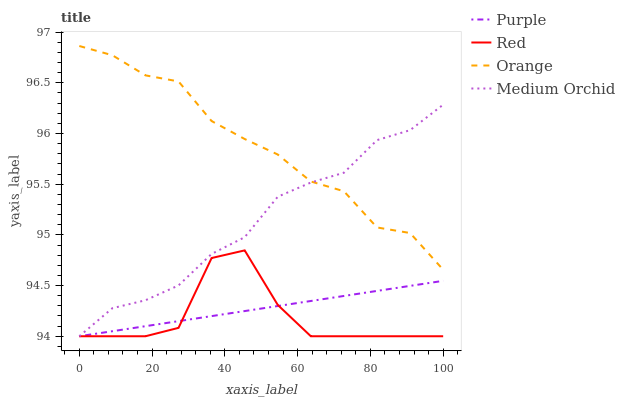Does Red have the minimum area under the curve?
Answer yes or no. Yes. Does Orange have the maximum area under the curve?
Answer yes or no. Yes. Does Medium Orchid have the minimum area under the curve?
Answer yes or no. No. Does Medium Orchid have the maximum area under the curve?
Answer yes or no. No. Is Purple the smoothest?
Answer yes or no. Yes. Is Red the roughest?
Answer yes or no. Yes. Is Orange the smoothest?
Answer yes or no. No. Is Orange the roughest?
Answer yes or no. No. Does Purple have the lowest value?
Answer yes or no. Yes. Does Orange have the lowest value?
Answer yes or no. No. Does Orange have the highest value?
Answer yes or no. Yes. Does Medium Orchid have the highest value?
Answer yes or no. No. Is Purple less than Orange?
Answer yes or no. Yes. Is Orange greater than Red?
Answer yes or no. Yes. Does Medium Orchid intersect Red?
Answer yes or no. Yes. Is Medium Orchid less than Red?
Answer yes or no. No. Is Medium Orchid greater than Red?
Answer yes or no. No. Does Purple intersect Orange?
Answer yes or no. No. 